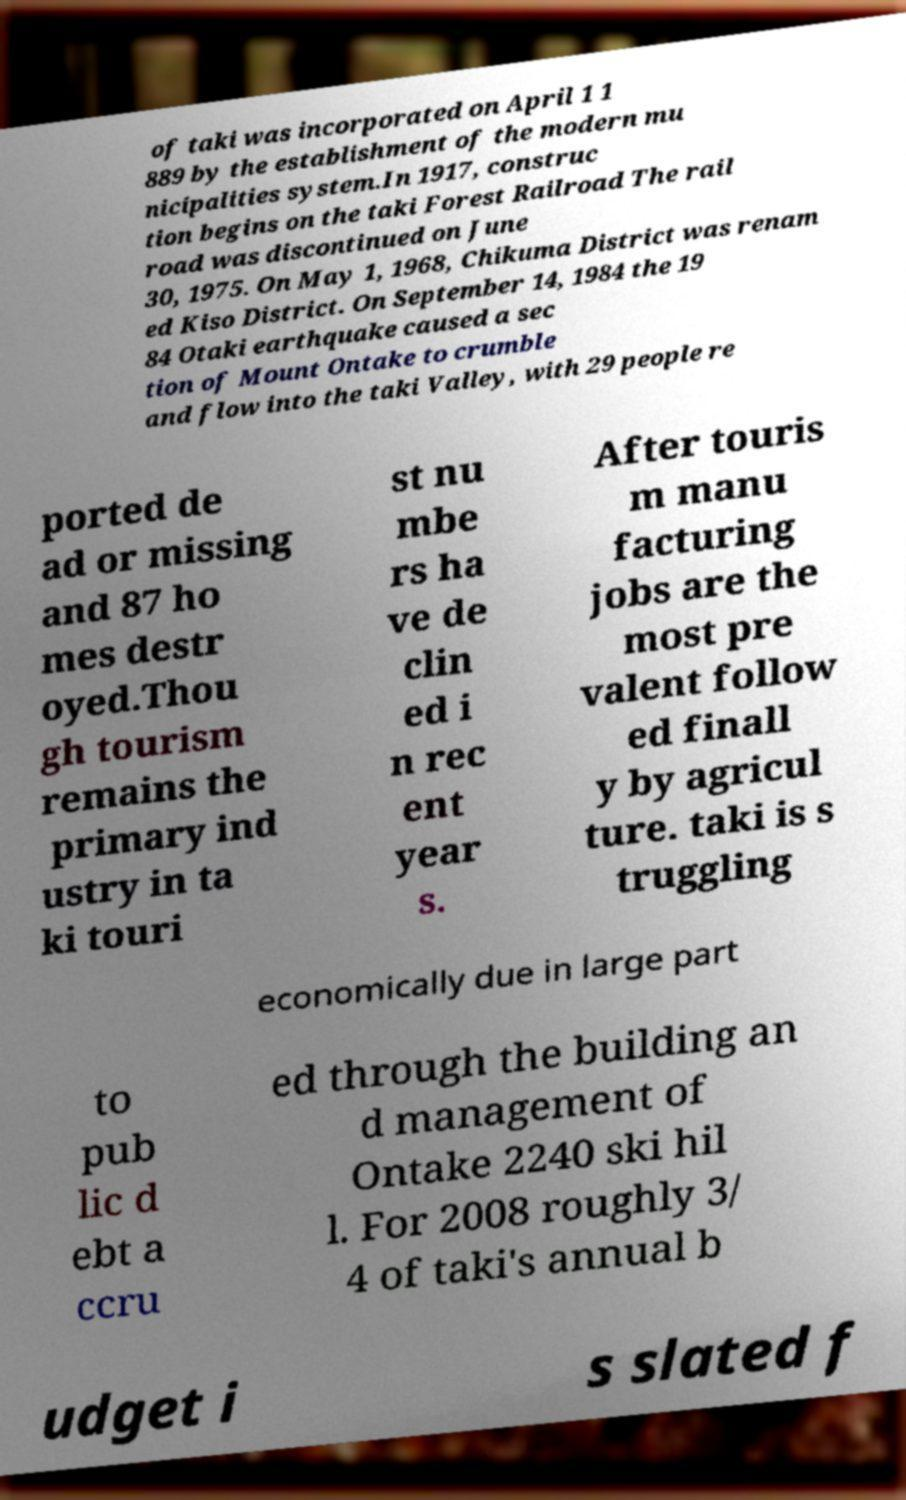Please read and relay the text visible in this image. What does it say? of taki was incorporated on April 1 1 889 by the establishment of the modern mu nicipalities system.In 1917, construc tion begins on the taki Forest Railroad The rail road was discontinued on June 30, 1975. On May 1, 1968, Chikuma District was renam ed Kiso District. On September 14, 1984 the 19 84 Otaki earthquake caused a sec tion of Mount Ontake to crumble and flow into the taki Valley, with 29 people re ported de ad or missing and 87 ho mes destr oyed.Thou gh tourism remains the primary ind ustry in ta ki touri st nu mbe rs ha ve de clin ed i n rec ent year s. After touris m manu facturing jobs are the most pre valent follow ed finall y by agricul ture. taki is s truggling economically due in large part to pub lic d ebt a ccru ed through the building an d management of Ontake 2240 ski hil l. For 2008 roughly 3/ 4 of taki's annual b udget i s slated f 